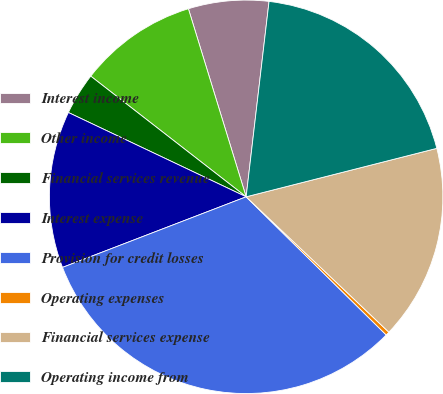Convert chart. <chart><loc_0><loc_0><loc_500><loc_500><pie_chart><fcel>Interest income<fcel>Other income<fcel>Financial services revenue<fcel>Interest expense<fcel>Provision for credit losses<fcel>Operating expenses<fcel>Financial services expense<fcel>Operating income from<nl><fcel>6.6%<fcel>9.75%<fcel>3.46%<fcel>12.89%<fcel>31.77%<fcel>0.31%<fcel>16.04%<fcel>19.18%<nl></chart> 